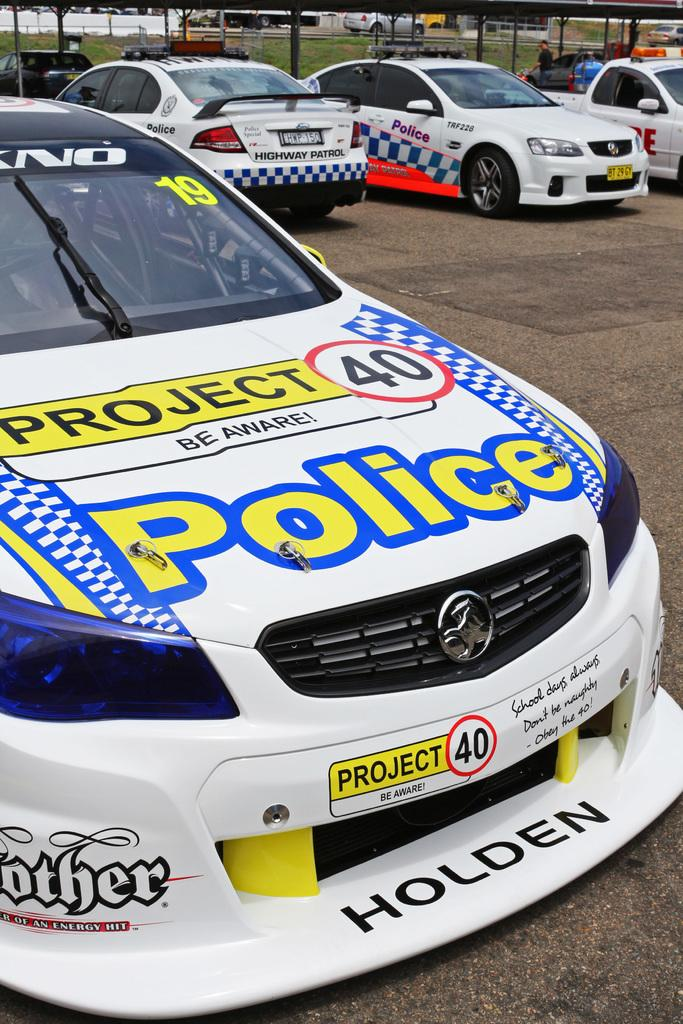What type of vehicles can be seen in the foreground of the image? There are cars in the foreground of the image. What structure is visible in the background of the image? There is a shed in the background of the image. Can you describe the person in the background of the image? There is a person in the background of the image, but no specific details about the person are provided. What might be the purpose of the building in the background of the image? There might be a building in the background of the image, but its purpose cannot be determined from the image. What is at the bottom of the image? There is a road and grass at the bottom of the image. How many cats are sitting on the stem in the image? There are no cats or stems present in the image. 